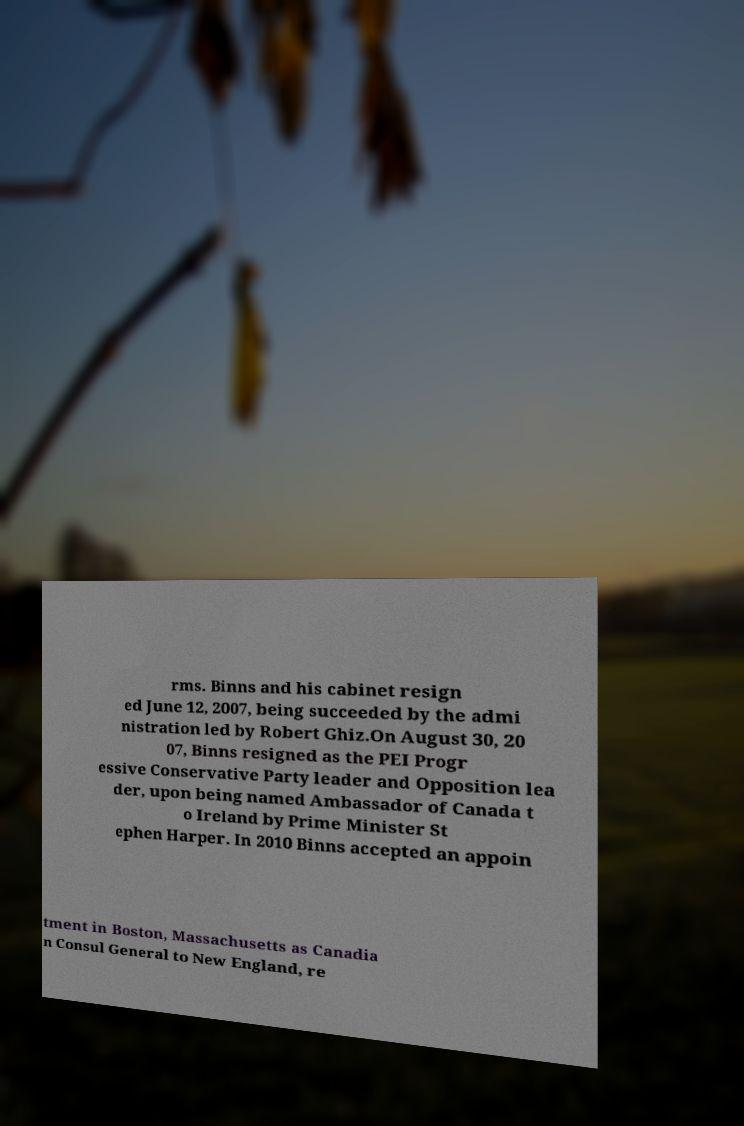Please read and relay the text visible in this image. What does it say? rms. Binns and his cabinet resign ed June 12, 2007, being succeeded by the admi nistration led by Robert Ghiz.On August 30, 20 07, Binns resigned as the PEI Progr essive Conservative Party leader and Opposition lea der, upon being named Ambassador of Canada t o Ireland by Prime Minister St ephen Harper. In 2010 Binns accepted an appoin tment in Boston, Massachusetts as Canadia n Consul General to New England, re 